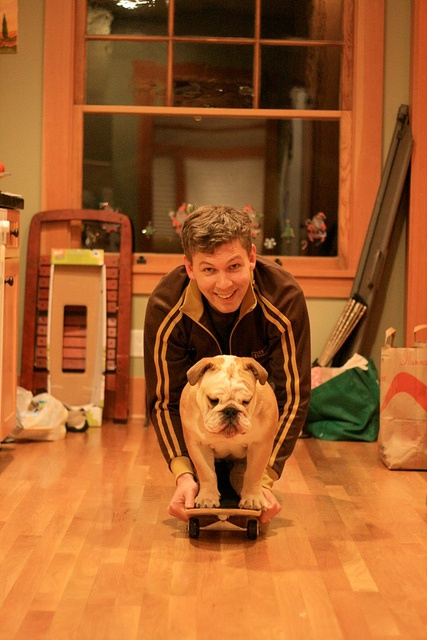Describe the objects in this image and their specific colors. I can see people in red, black, maroon, and brown tones, dog in red, orange, and brown tones, handbag in red, darkgreen, black, and brown tones, and skateboard in red, black, maroon, and brown tones in this image. 